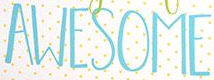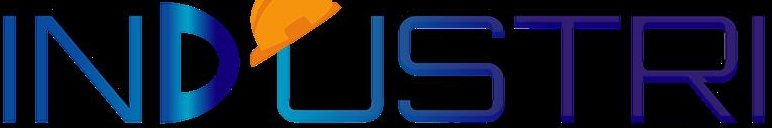What text is displayed in these images sequentially, separated by a semicolon? AWESOME; INDUSTRI 